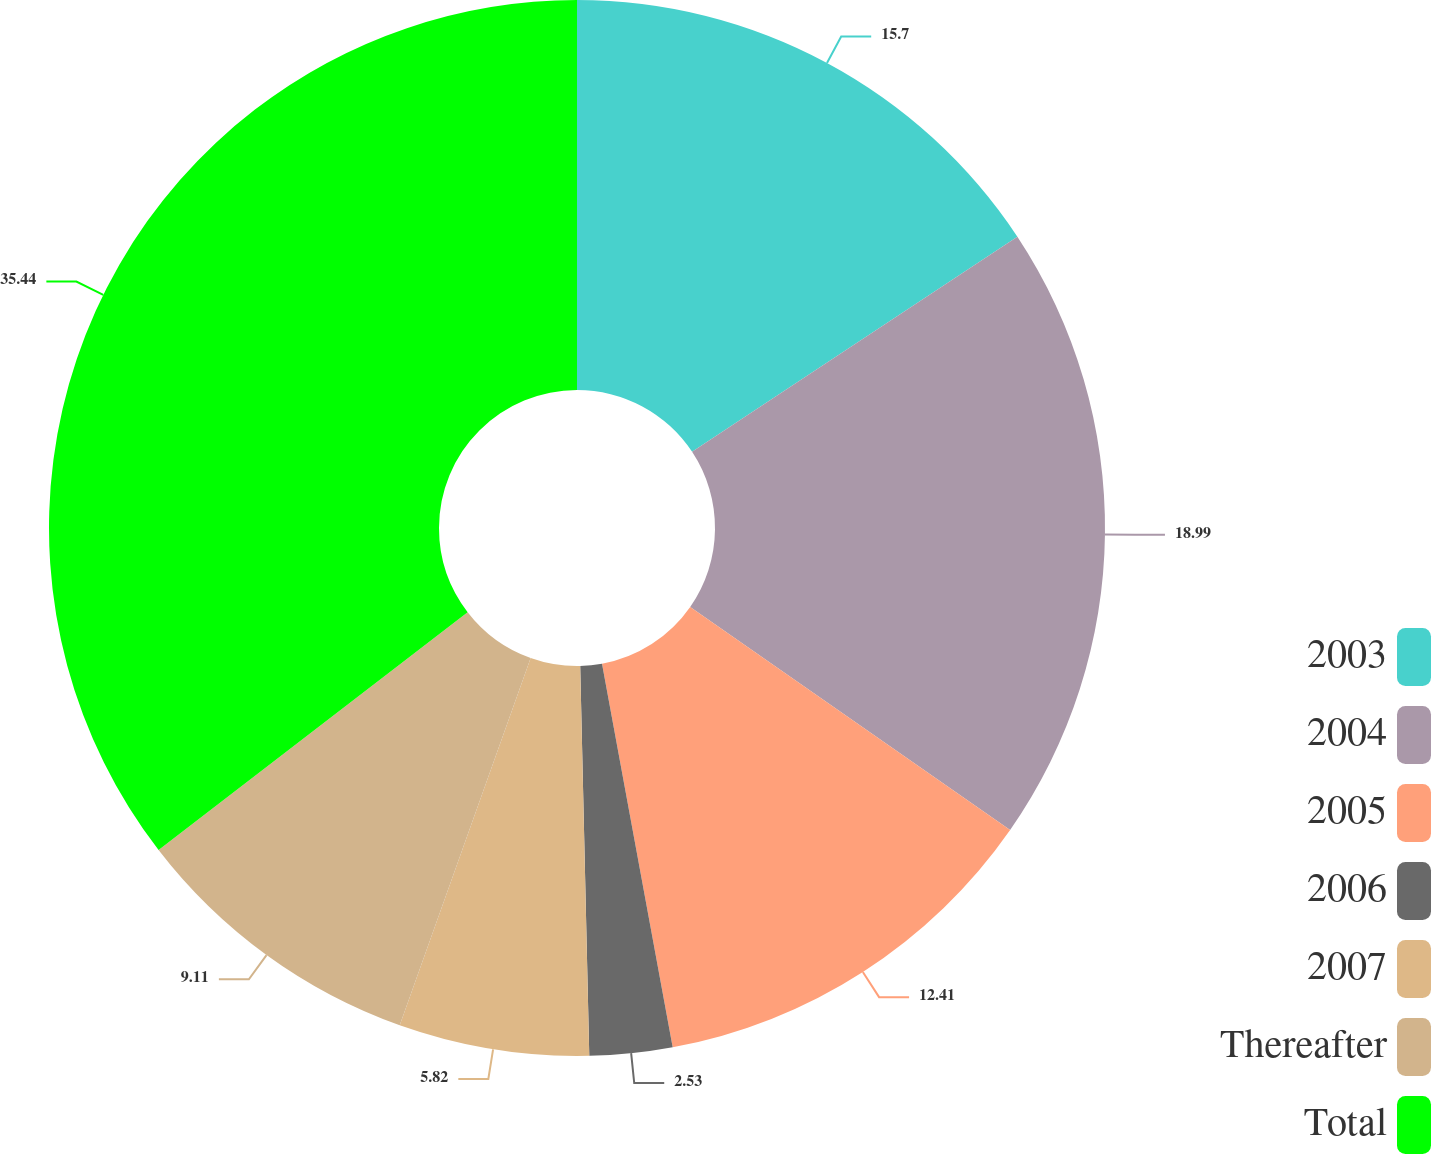Convert chart. <chart><loc_0><loc_0><loc_500><loc_500><pie_chart><fcel>2003<fcel>2004<fcel>2005<fcel>2006<fcel>2007<fcel>Thereafter<fcel>Total<nl><fcel>15.7%<fcel>18.99%<fcel>12.41%<fcel>2.53%<fcel>5.82%<fcel>9.11%<fcel>35.44%<nl></chart> 